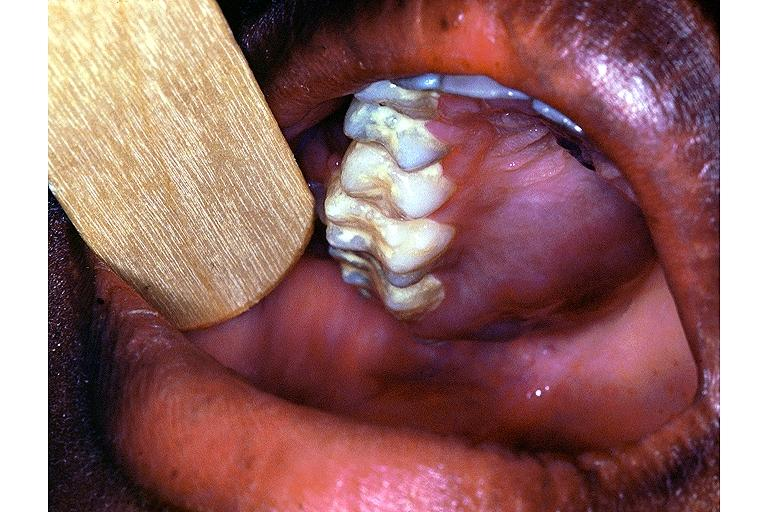where is this?
Answer the question using a single word or phrase. Oral 